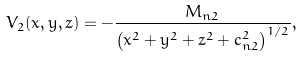Convert formula to latex. <formula><loc_0><loc_0><loc_500><loc_500>V _ { 2 } ( x , y , z ) = - \frac { M _ { n 2 } } { \left ( x ^ { 2 } + y ^ { 2 } + z ^ { 2 } + c _ { n 2 } ^ { 2 } \right ) ^ { 1 / 2 } } ,</formula> 